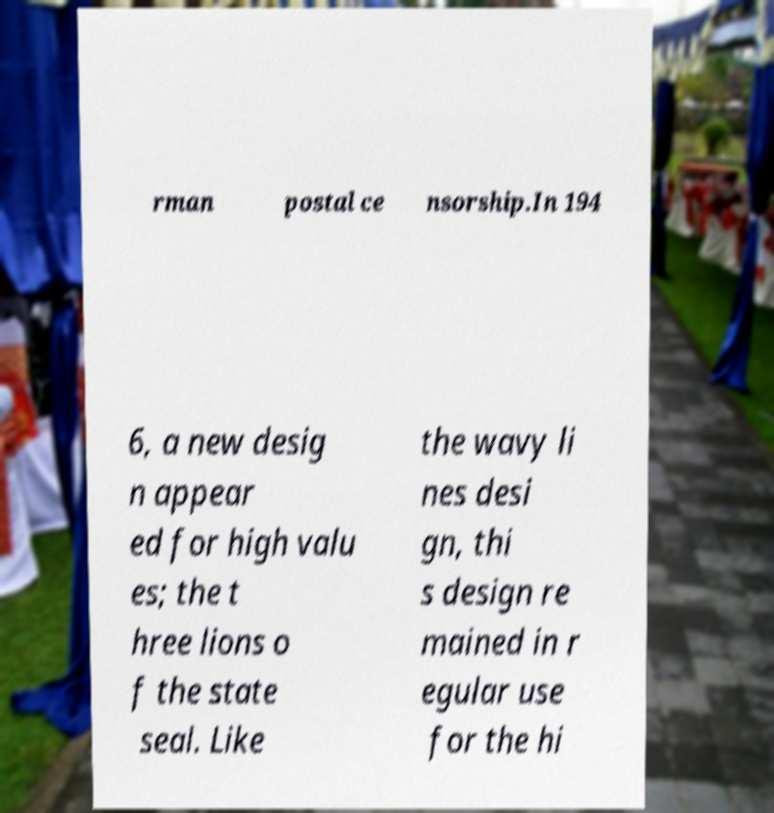Please identify and transcribe the text found in this image. rman postal ce nsorship.In 194 6, a new desig n appear ed for high valu es; the t hree lions o f the state seal. Like the wavy li nes desi gn, thi s design re mained in r egular use for the hi 